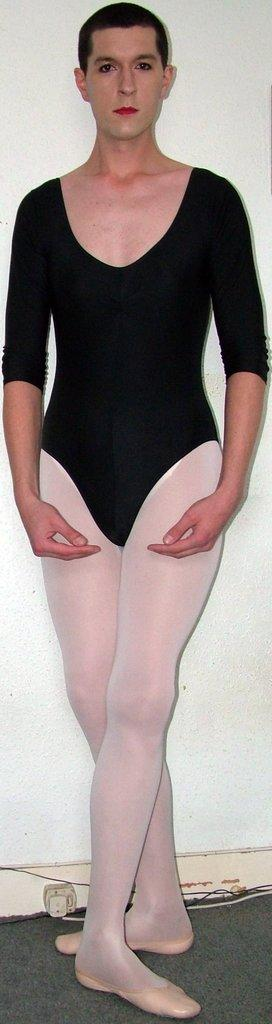What is the main subject of the image? There is a person standing in the image. What is the person standing on? The person is standing on the floor. What can be seen behind the person in the image? There is an off-white wall in the background of the image. Where was the image taken? The image was taken in a room. What type of boat does the person's father own, as seen in the image? There is no boat or reference to a father in the image; it only features a person standing in a room. 